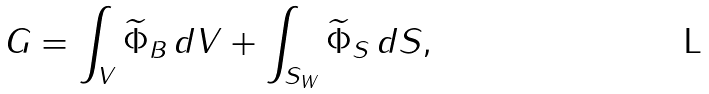<formula> <loc_0><loc_0><loc_500><loc_500>G = \int _ { V } \widetilde { \Phi } _ { B } \, d V + \int _ { S _ { W } } \widetilde { \Phi } _ { S } \, d S ,</formula> 